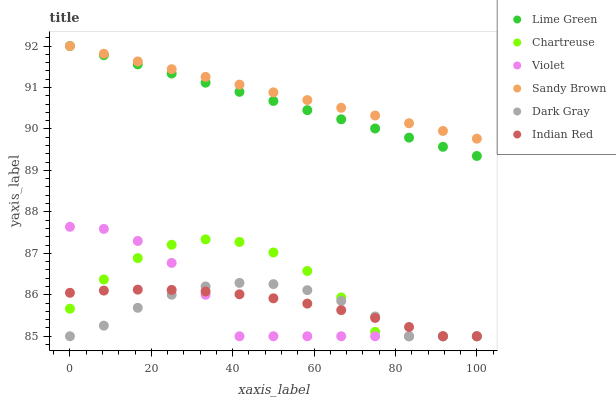Does Dark Gray have the minimum area under the curve?
Answer yes or no. Yes. Does Sandy Brown have the maximum area under the curve?
Answer yes or no. Yes. Does Chartreuse have the minimum area under the curve?
Answer yes or no. No. Does Chartreuse have the maximum area under the curve?
Answer yes or no. No. Is Lime Green the smoothest?
Answer yes or no. Yes. Is Chartreuse the roughest?
Answer yes or no. Yes. Is Dark Gray the smoothest?
Answer yes or no. No. Is Dark Gray the roughest?
Answer yes or no. No. Does Dark Gray have the lowest value?
Answer yes or no. Yes. Does Sandy Brown have the lowest value?
Answer yes or no. No. Does Sandy Brown have the highest value?
Answer yes or no. Yes. Does Dark Gray have the highest value?
Answer yes or no. No. Is Dark Gray less than Sandy Brown?
Answer yes or no. Yes. Is Lime Green greater than Chartreuse?
Answer yes or no. Yes. Does Violet intersect Indian Red?
Answer yes or no. Yes. Is Violet less than Indian Red?
Answer yes or no. No. Is Violet greater than Indian Red?
Answer yes or no. No. Does Dark Gray intersect Sandy Brown?
Answer yes or no. No. 